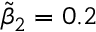Convert formula to latex. <formula><loc_0><loc_0><loc_500><loc_500>\widetilde { \beta } _ { 2 } = 0 . 2</formula> 